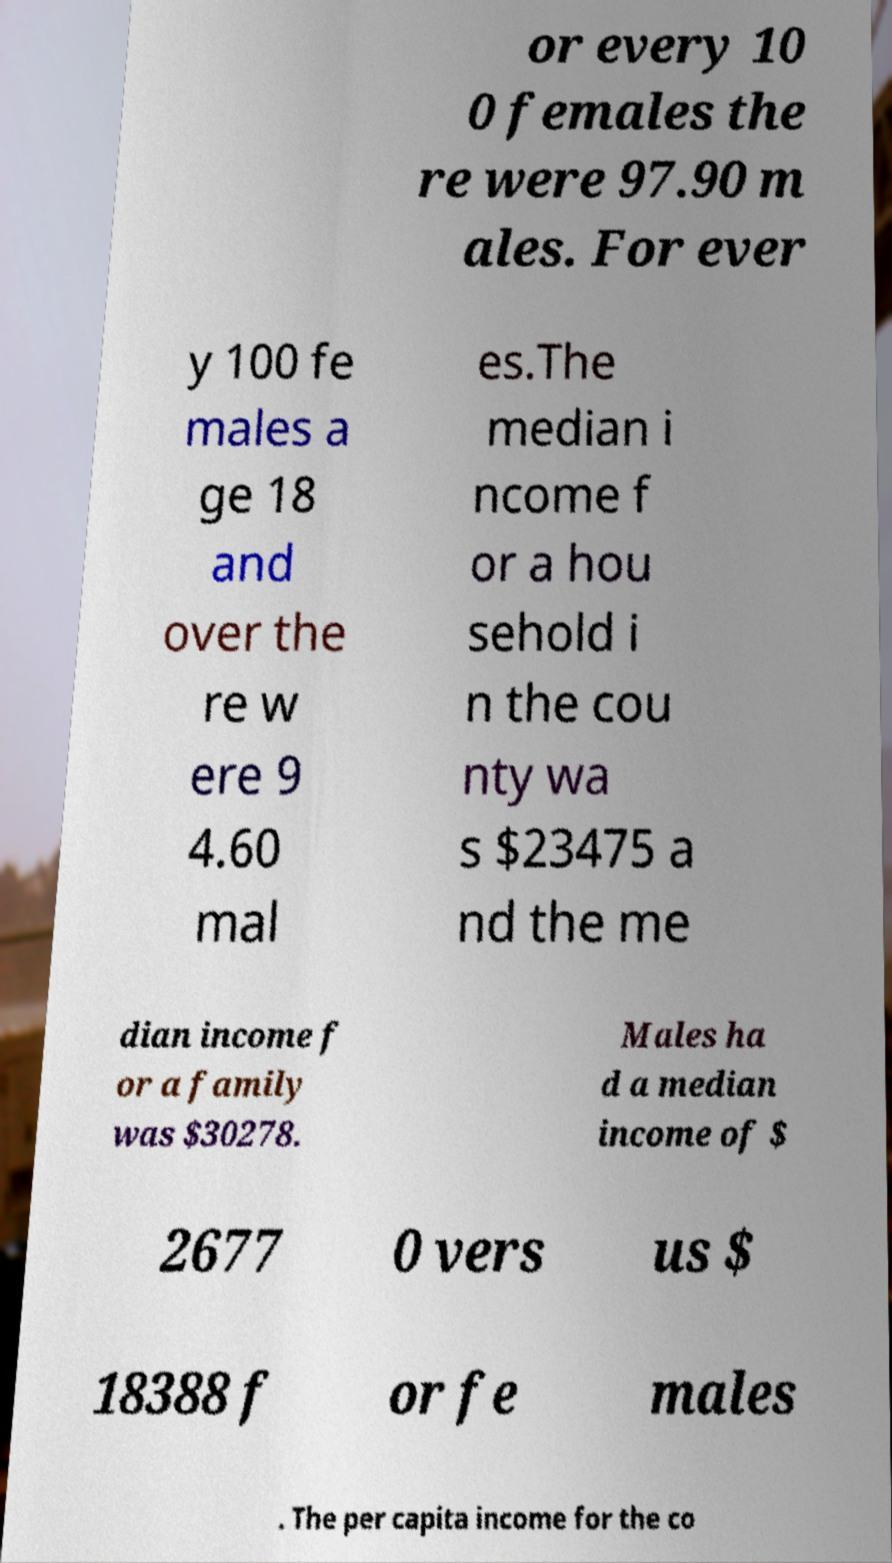Please read and relay the text visible in this image. What does it say? or every 10 0 females the re were 97.90 m ales. For ever y 100 fe males a ge 18 and over the re w ere 9 4.60 mal es.The median i ncome f or a hou sehold i n the cou nty wa s $23475 a nd the me dian income f or a family was $30278. Males ha d a median income of $ 2677 0 vers us $ 18388 f or fe males . The per capita income for the co 